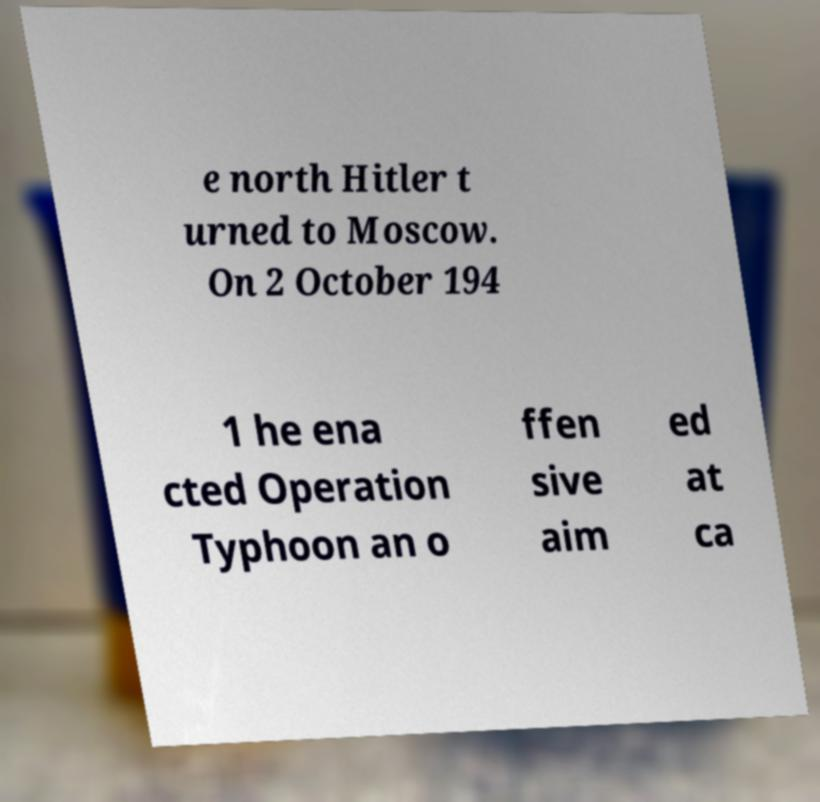For documentation purposes, I need the text within this image transcribed. Could you provide that? e north Hitler t urned to Moscow. On 2 October 194 1 he ena cted Operation Typhoon an o ffen sive aim ed at ca 